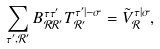Convert formula to latex. <formula><loc_0><loc_0><loc_500><loc_500>\sum _ { \tau ^ { \prime } , \mathcal { R } ^ { \prime } } B _ { \mathcal { R } \mathcal { R } ^ { \prime } } ^ { \tau \tau ^ { \prime } } T ^ { \tau ^ { \prime } | - \sigma } _ { \mathcal { R } ^ { \prime } } = \tilde { V } _ { \mathcal { R } } ^ { \tau | \sigma } ,</formula> 